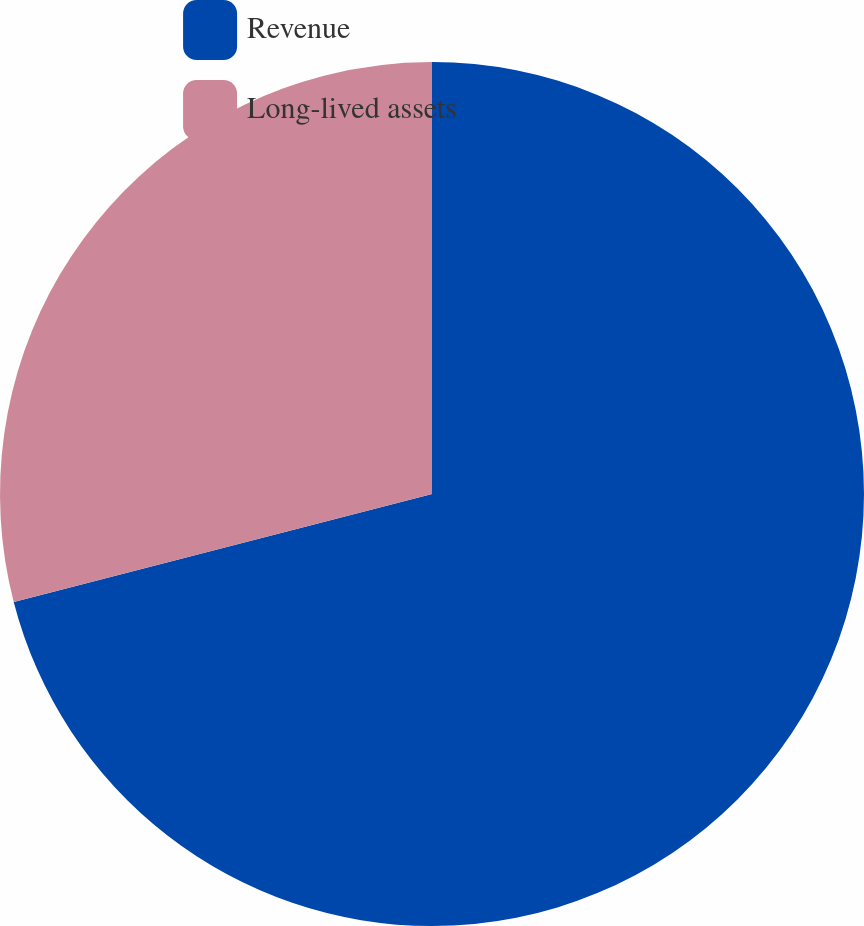<chart> <loc_0><loc_0><loc_500><loc_500><pie_chart><fcel>Revenue<fcel>Long-lived assets<nl><fcel>70.98%<fcel>29.02%<nl></chart> 